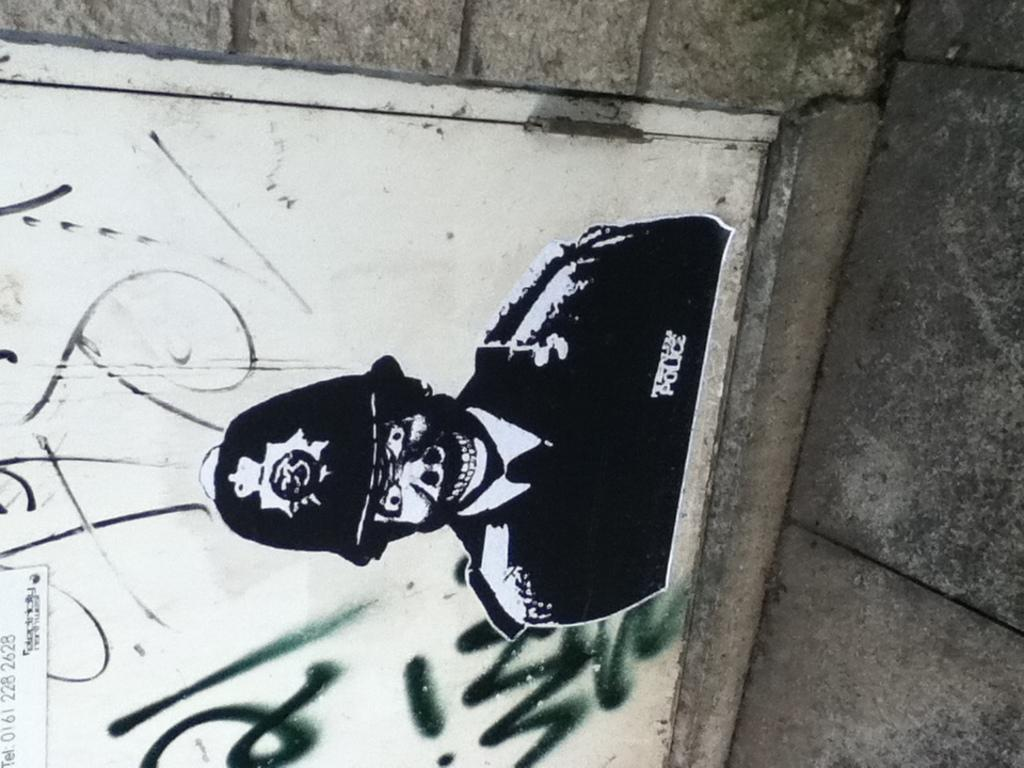What is depicted on the door in the image? There is a picture of a person on the door. What else can be seen on the door besides the picture? There is text and numbers on the door. What type of structure is visible beside the door? There is a rock wall beside the door. How many snakes are slithering down the slope in the image? There are no snakes or slopes present in the image. What type of gun is visible on the door? There is no gun present in the image. 